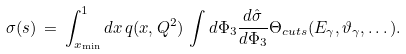<formula> <loc_0><loc_0><loc_500><loc_500>\sigma ( s ) \, = \, \int ^ { 1 } _ { x _ { \min } } d x \, q ( x , Q ^ { 2 } ) \, \int d \Phi _ { 3 } \frac { d \hat { \sigma } } { d \Phi _ { 3 } } \Theta _ { c u t s } ( E _ { \gamma } , \vartheta _ { \gamma } , \dots ) .</formula> 